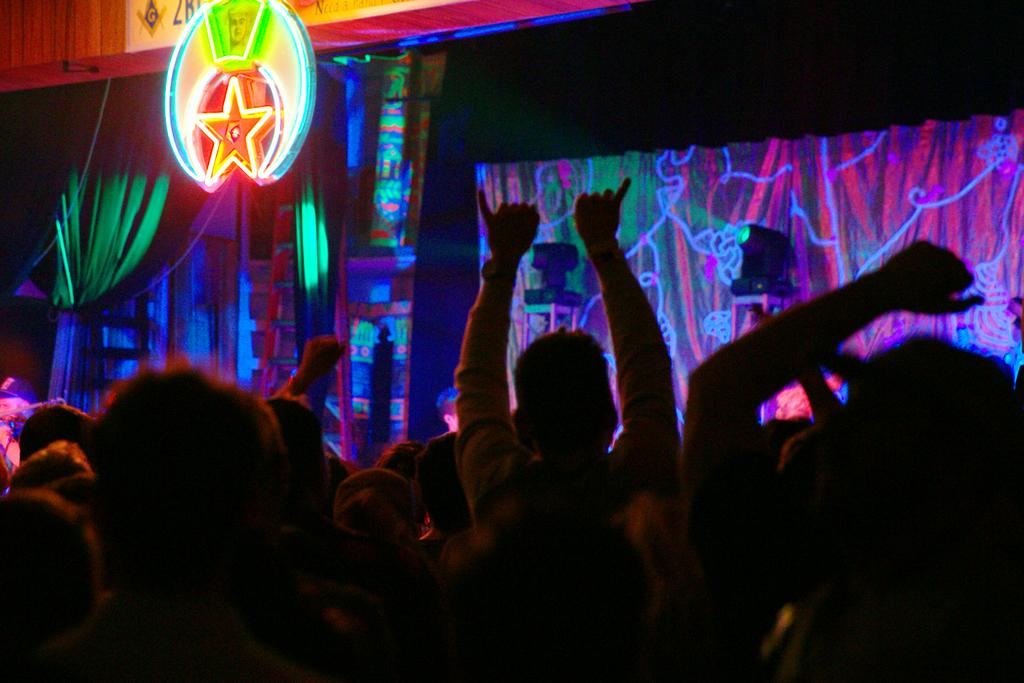Who or what is present in the image? There are people in the image. What can be seen in the background of the image? There are lights, curtains, ladders, and a board with lights in the background of the image. Can you see a pin holding up the curtains in the image? There is no pin visible in the image; the curtains are not being held up by a pin. 